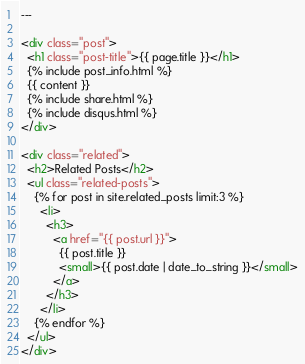Convert code to text. <code><loc_0><loc_0><loc_500><loc_500><_HTML_>---

<div class="post">
  <h1 class="post-title">{{ page.title }}</h1>
  {% include post_info.html %}
  {{ content }}
  {% include share.html %}
  {% include disqus.html %}
</div>

<div class="related">
  <h2>Related Posts</h2>
  <ul class="related-posts">
    {% for post in site.related_posts limit:3 %}
      <li>
        <h3>
          <a href="{{ post.url }}">
            {{ post.title }}
            <small>{{ post.date | date_to_string }}</small>
          </a>
        </h3>
      </li>
    {% endfor %}
  </ul>
</div>
</code> 